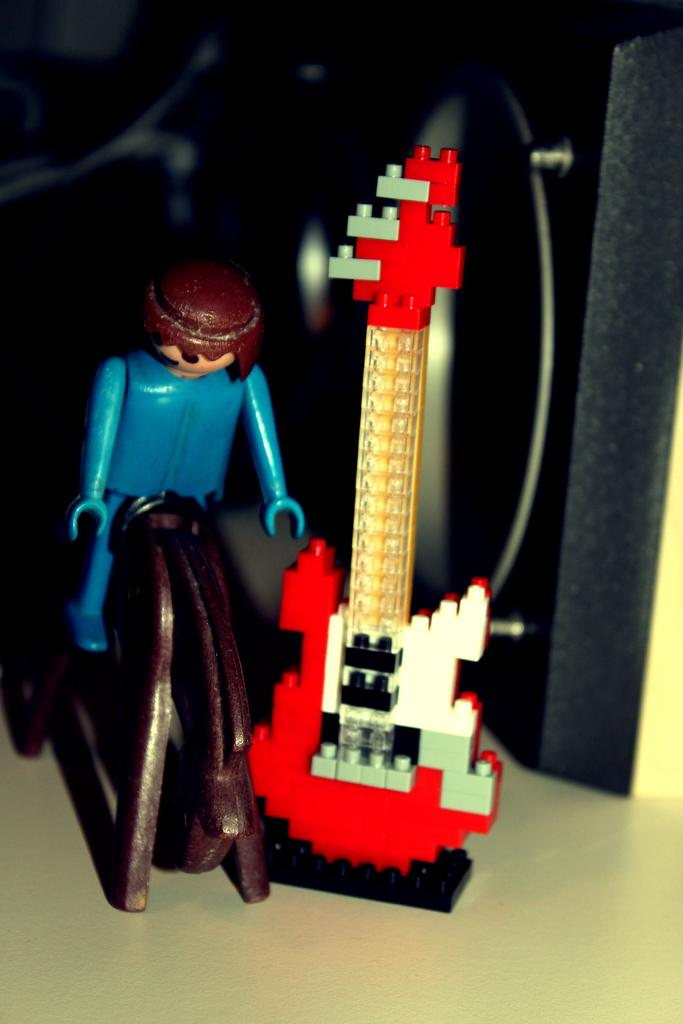What is the main subject at the bottom of the image? There is a toy person sitting on a toy animal at the bottom of the image. What other toy is present beside the toy animal? There is a toy guitar beside the toy animal. Can you describe any other objects visible in the background of the image? Unfortunately, the provided facts do not give any information about objects in the background. What type of metal is used to make the crook in the image? There is no crook present in the image, so it is not possible to determine what type of metal might be used. 